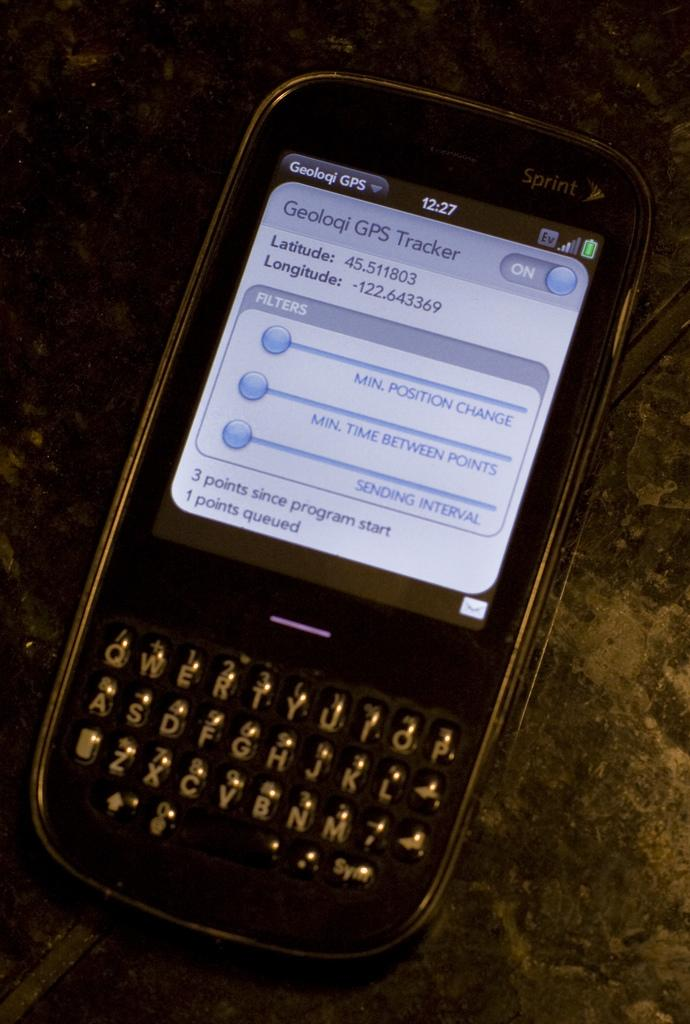<image>
Write a terse but informative summary of the picture. Sprint phone screen that says "Geoloqi GPS Tracker" on it. 